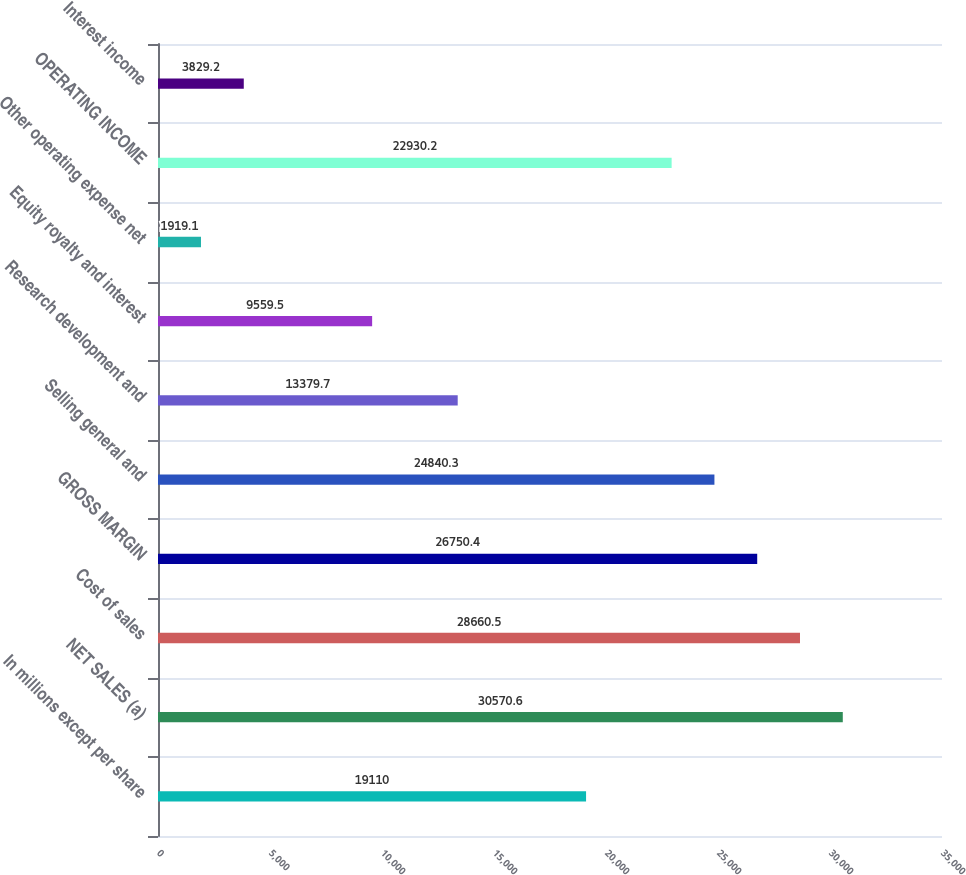Convert chart. <chart><loc_0><loc_0><loc_500><loc_500><bar_chart><fcel>In millions except per share<fcel>NET SALES (a)<fcel>Cost of sales<fcel>GROSS MARGIN<fcel>Selling general and<fcel>Research development and<fcel>Equity royalty and interest<fcel>Other operating expense net<fcel>OPERATING INCOME<fcel>Interest income<nl><fcel>19110<fcel>30570.6<fcel>28660.5<fcel>26750.4<fcel>24840.3<fcel>13379.7<fcel>9559.5<fcel>1919.1<fcel>22930.2<fcel>3829.2<nl></chart> 